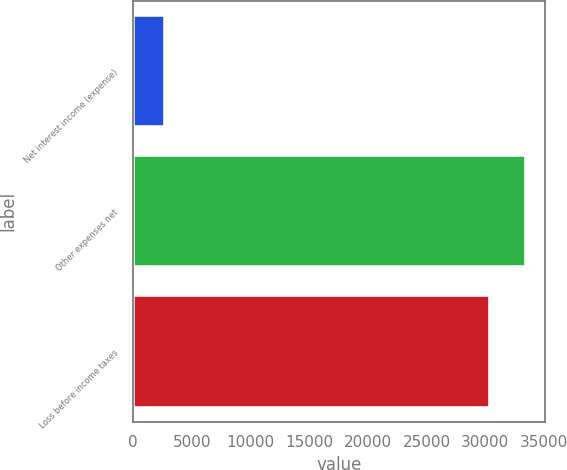<chart> <loc_0><loc_0><loc_500><loc_500><bar_chart><fcel>Net interest income (expense)<fcel>Other expenses net<fcel>Loss before income taxes<nl><fcel>2731<fcel>33430.1<fcel>30391<nl></chart> 